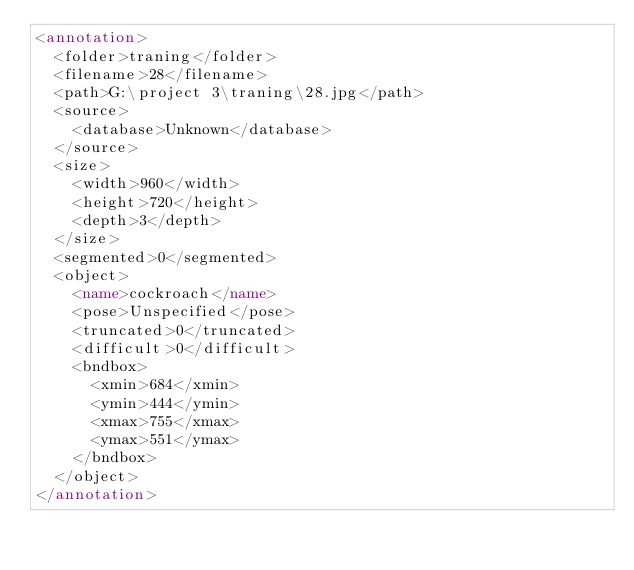Convert code to text. <code><loc_0><loc_0><loc_500><loc_500><_XML_><annotation>
  <folder>traning</folder>
  <filename>28</filename>
  <path>G:\project 3\traning\28.jpg</path>
  <source>
    <database>Unknown</database>
  </source>
  <size>
    <width>960</width>
    <height>720</height>
    <depth>3</depth>
  </size>
  <segmented>0</segmented>
  <object>
    <name>cockroach</name>
    <pose>Unspecified</pose>
    <truncated>0</truncated>
    <difficult>0</difficult>
    <bndbox>
      <xmin>684</xmin>
      <ymin>444</ymin>
      <xmax>755</xmax>
      <ymax>551</ymax>
    </bndbox>
  </object>
</annotation>
</code> 